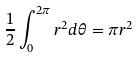Convert formula to latex. <formula><loc_0><loc_0><loc_500><loc_500>\frac { 1 } { 2 } \int _ { 0 } ^ { 2 \pi } r ^ { 2 } d \theta = \pi r ^ { 2 }</formula> 